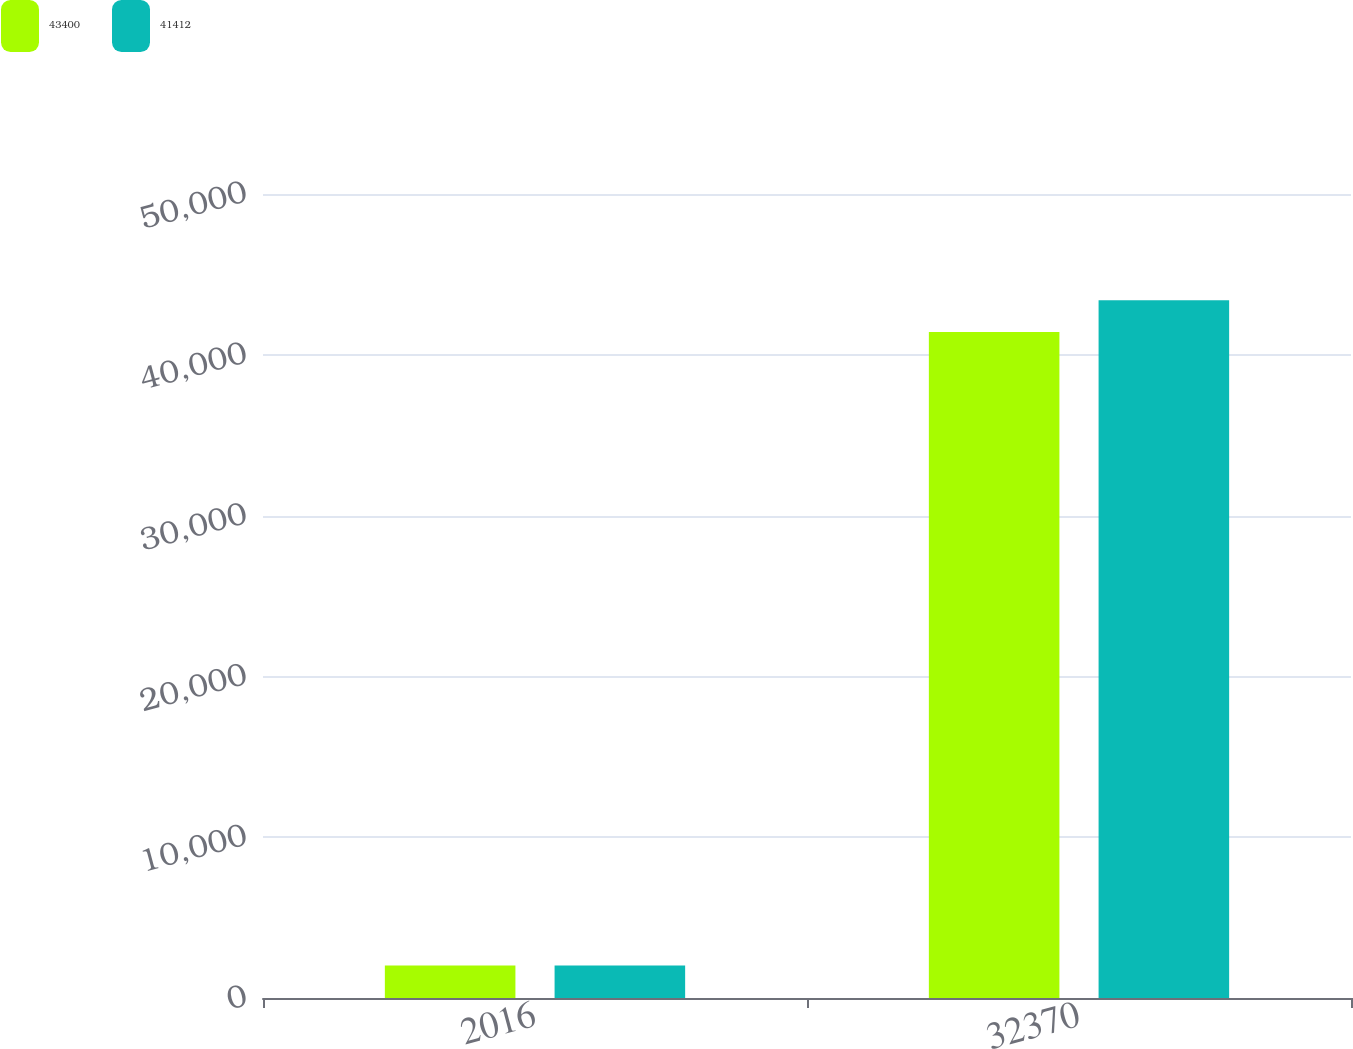Convert chart. <chart><loc_0><loc_0><loc_500><loc_500><stacked_bar_chart><ecel><fcel>2016<fcel>32370<nl><fcel>43400<fcel>2015<fcel>41412<nl><fcel>41412<fcel>2014<fcel>43400<nl></chart> 